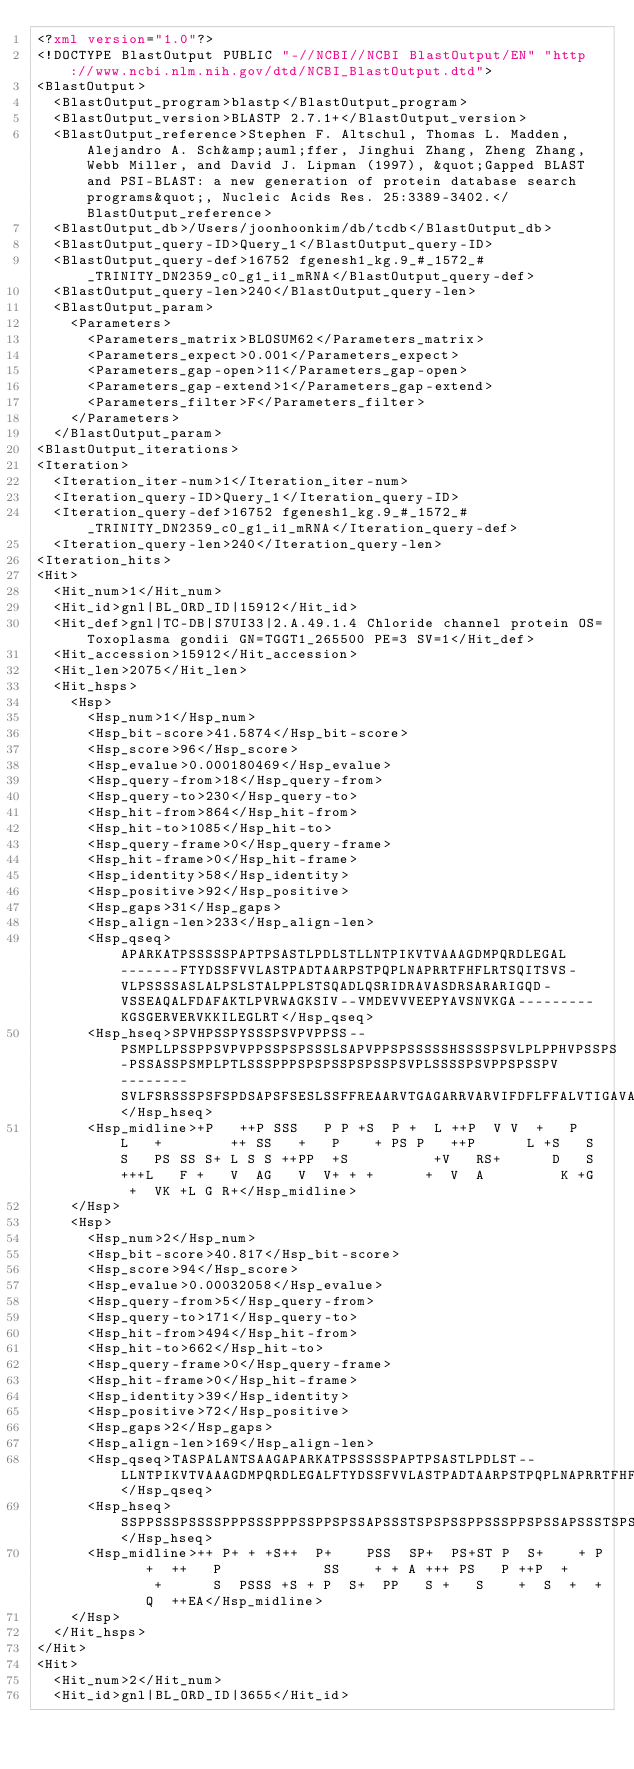<code> <loc_0><loc_0><loc_500><loc_500><_XML_><?xml version="1.0"?>
<!DOCTYPE BlastOutput PUBLIC "-//NCBI//NCBI BlastOutput/EN" "http://www.ncbi.nlm.nih.gov/dtd/NCBI_BlastOutput.dtd">
<BlastOutput>
  <BlastOutput_program>blastp</BlastOutput_program>
  <BlastOutput_version>BLASTP 2.7.1+</BlastOutput_version>
  <BlastOutput_reference>Stephen F. Altschul, Thomas L. Madden, Alejandro A. Sch&amp;auml;ffer, Jinghui Zhang, Zheng Zhang, Webb Miller, and David J. Lipman (1997), &quot;Gapped BLAST and PSI-BLAST: a new generation of protein database search programs&quot;, Nucleic Acids Res. 25:3389-3402.</BlastOutput_reference>
  <BlastOutput_db>/Users/joonhoonkim/db/tcdb</BlastOutput_db>
  <BlastOutput_query-ID>Query_1</BlastOutput_query-ID>
  <BlastOutput_query-def>16752 fgenesh1_kg.9_#_1572_#_TRINITY_DN2359_c0_g1_i1_mRNA</BlastOutput_query-def>
  <BlastOutput_query-len>240</BlastOutput_query-len>
  <BlastOutput_param>
    <Parameters>
      <Parameters_matrix>BLOSUM62</Parameters_matrix>
      <Parameters_expect>0.001</Parameters_expect>
      <Parameters_gap-open>11</Parameters_gap-open>
      <Parameters_gap-extend>1</Parameters_gap-extend>
      <Parameters_filter>F</Parameters_filter>
    </Parameters>
  </BlastOutput_param>
<BlastOutput_iterations>
<Iteration>
  <Iteration_iter-num>1</Iteration_iter-num>
  <Iteration_query-ID>Query_1</Iteration_query-ID>
  <Iteration_query-def>16752 fgenesh1_kg.9_#_1572_#_TRINITY_DN2359_c0_g1_i1_mRNA</Iteration_query-def>
  <Iteration_query-len>240</Iteration_query-len>
<Iteration_hits>
<Hit>
  <Hit_num>1</Hit_num>
  <Hit_id>gnl|BL_ORD_ID|15912</Hit_id>
  <Hit_def>gnl|TC-DB|S7UI33|2.A.49.1.4 Chloride channel protein OS=Toxoplasma gondii GN=TGGT1_265500 PE=3 SV=1</Hit_def>
  <Hit_accession>15912</Hit_accession>
  <Hit_len>2075</Hit_len>
  <Hit_hsps>
    <Hsp>
      <Hsp_num>1</Hsp_num>
      <Hsp_bit-score>41.5874</Hsp_bit-score>
      <Hsp_score>96</Hsp_score>
      <Hsp_evalue>0.000180469</Hsp_evalue>
      <Hsp_query-from>18</Hsp_query-from>
      <Hsp_query-to>230</Hsp_query-to>
      <Hsp_hit-from>864</Hsp_hit-from>
      <Hsp_hit-to>1085</Hsp_hit-to>
      <Hsp_query-frame>0</Hsp_query-frame>
      <Hsp_hit-frame>0</Hsp_hit-frame>
      <Hsp_identity>58</Hsp_identity>
      <Hsp_positive>92</Hsp_positive>
      <Hsp_gaps>31</Hsp_gaps>
      <Hsp_align-len>233</Hsp_align-len>
      <Hsp_qseq>APARKATPSSSSSPAPTPSASTLPDLSTLLNTPIKVTVAAAGDMPQRDLEGAL-------FTYDSSFVVLASTPADTAARPSTPQPLNAPRRTFHFLRTSQITSVS-VLPSSSSASLALPSLSTALPPLSTSQADLQSRIDRAVASDRSARARIGQD-VSSEAQALFDAFAKTLPVRWAGKSIV--VMDEVVVEEPYAVSNVKGA---------KGSGERVERVKKILEGLRT</Hsp_qseq>
      <Hsp_hseq>SPVHPSSPYSSSPSVPVPPSS--PSMPLLPSSPPSVPVPPSSPSPSSSLSAPVPPSPSSSSSHSSSSPSVLPLPPHVPSSPS-PSSASSPSMPLPTLSSSPPPSPSPSSPSPSSPSVPLSSSSPSVPPSPSSPV--------SVLFSRSSSPSFSPDSAPSFSESLSSFFREAARVTGAGARRVARVIFDFLFFALVTIGAVAAAAWLVCALAPKAAGSGIAEVKVLLNGFRS</Hsp_hseq>
      <Hsp_midline>+P   ++P SSS   P P +S  P +  L ++P  V V  +   P   L   +        ++ SS   +   P    + PS P   ++P      L +S   S S   PS SS S+ L S S ++PP  +S          +V   RS+      D   S +++L   F +   V  AG   V  V+ + +      +  V  A         K +G  +  VK +L G R+</Hsp_midline>
    </Hsp>
    <Hsp>
      <Hsp_num>2</Hsp_num>
      <Hsp_bit-score>40.817</Hsp_bit-score>
      <Hsp_score>94</Hsp_score>
      <Hsp_evalue>0.00032058</Hsp_evalue>
      <Hsp_query-from>5</Hsp_query-from>
      <Hsp_query-to>171</Hsp_query-to>
      <Hsp_hit-from>494</Hsp_hit-from>
      <Hsp_hit-to>662</Hsp_hit-to>
      <Hsp_query-frame>0</Hsp_query-frame>
      <Hsp_hit-frame>0</Hsp_hit-frame>
      <Hsp_identity>39</Hsp_identity>
      <Hsp_positive>72</Hsp_positive>
      <Hsp_gaps>2</Hsp_gaps>
      <Hsp_align-len>169</Hsp_align-len>
      <Hsp_qseq>TASPALANTSAAGAPARKATPSSSSSPAPTPSASTLPDLST--LLNTPIKVTVAAAGDMPQRDLEGALFTYDSSFVVLASTPADTAARPSTPQPLNAPRRTFHFLRTSQITSVSVLPSSSSASLALPSLSTALPPLSTSQADLQSRIDRAVASDRSARARIGQDVSSEA</Hsp_qseq>
      <Hsp_hseq>SSPPSSSPSSSSPPPSSSPPPSSPPSPSSAPSSSTSPSPSSPPSSSPPSPSSAPSSSTSPSPSSPPPSSPPSSSSTSPSPSSAPSSSPPSPSPPPSSPPSSSSTSPSPSSAPSSSPPSSSPSSSSPPPSSSPPPPSPPSSSPPSSSSPSSSPSPSADLSERAQGPANEA</Hsp_hseq>
      <Hsp_midline>++ P+ + +S++  P+    PSS  SP+  PS+ST P  S+    + P   +  ++   P            SS    + + A +++ PS   P ++P  +     +      S  PSSS +S + P  S+  PP   S +   S    +  S  +  +   Q  ++EA</Hsp_midline>
    </Hsp>
  </Hit_hsps>
</Hit>
<Hit>
  <Hit_num>2</Hit_num>
  <Hit_id>gnl|BL_ORD_ID|3655</Hit_id></code> 